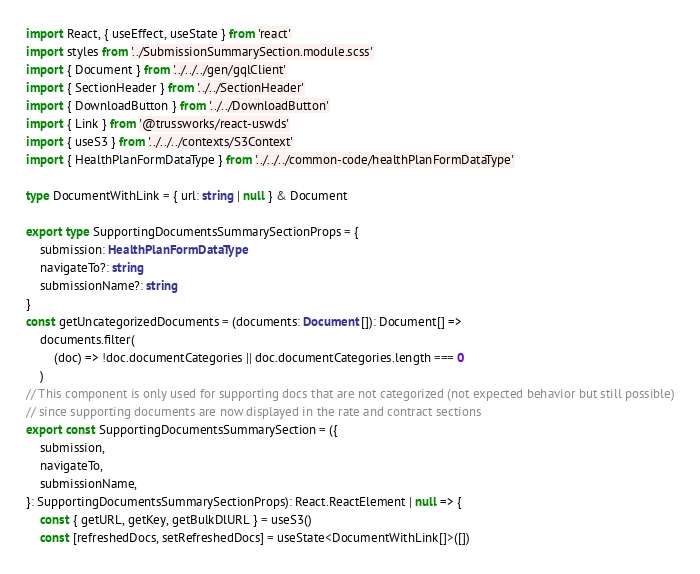Convert code to text. <code><loc_0><loc_0><loc_500><loc_500><_TypeScript_>import React, { useEffect, useState } from 'react'
import styles from '../SubmissionSummarySection.module.scss'
import { Document } from '../../../gen/gqlClient'
import { SectionHeader } from '../../SectionHeader'
import { DownloadButton } from '../../DownloadButton'
import { Link } from '@trussworks/react-uswds'
import { useS3 } from '../../../contexts/S3Context'
import { HealthPlanFormDataType } from '../../../common-code/healthPlanFormDataType'

type DocumentWithLink = { url: string | null } & Document

export type SupportingDocumentsSummarySectionProps = {
    submission: HealthPlanFormDataType
    navigateTo?: string
    submissionName?: string
}
const getUncategorizedDocuments = (documents: Document[]): Document[] =>
    documents.filter(
        (doc) => !doc.documentCategories || doc.documentCategories.length === 0
    )
// This component is only used for supporting docs that are not categorized (not expected behavior but still possible)
// since supporting documents are now displayed in the rate and contract sections
export const SupportingDocumentsSummarySection = ({
    submission,
    navigateTo,
    submissionName,
}: SupportingDocumentsSummarySectionProps): React.ReactElement | null => {
    const { getURL, getKey, getBulkDlURL } = useS3()
    const [refreshedDocs, setRefreshedDocs] = useState<DocumentWithLink[]>([])</code> 